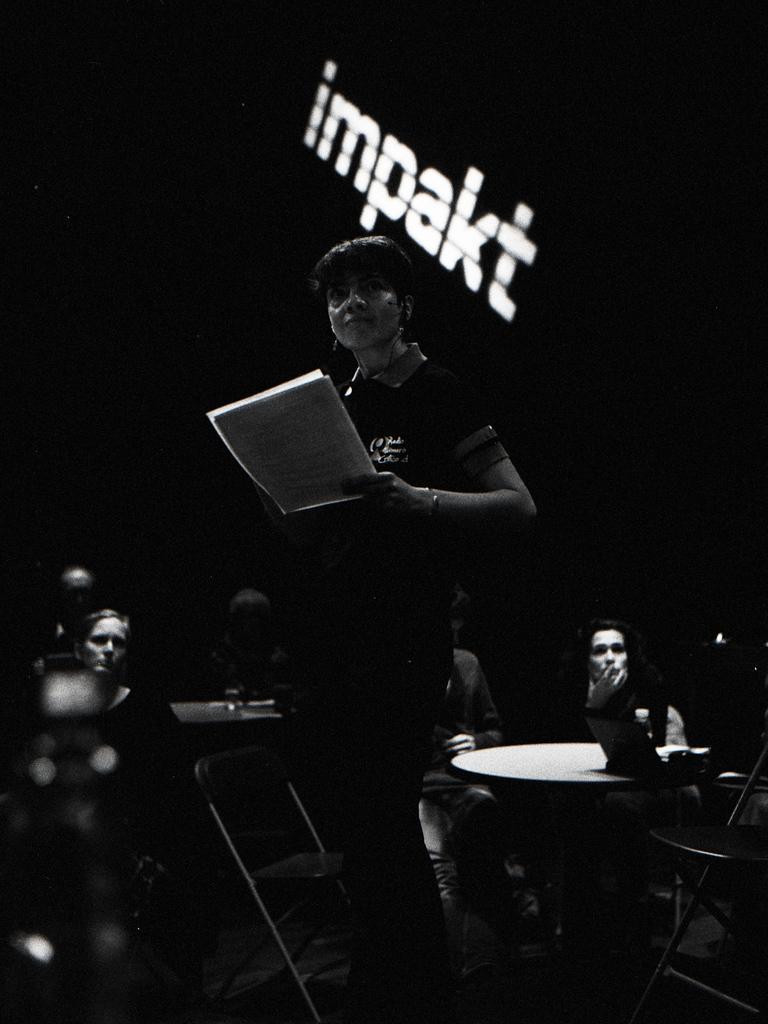How would you summarize this image in a sentence or two? This is a black and white image. In this image we can see a woman standing by holding papers in her hands and people sitting on the chairs and tables are placed in front of them. 